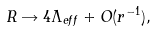<formula> <loc_0><loc_0><loc_500><loc_500>R \rightarrow 4 \Lambda _ { e f f } + O ( r ^ { - 1 } ) ,</formula> 